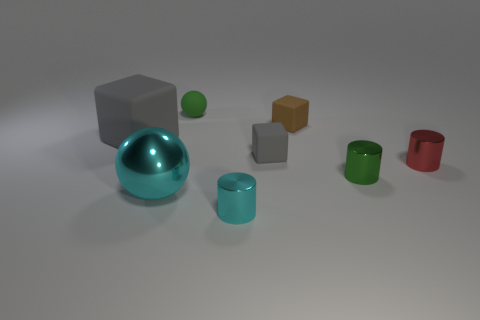How does the lighting in the image contribute to the objects' appearance? The lighting in the image is coming from above, creating soft shadows beneath each object. The gentle lighting enhances the three-dimensionality of the objects and highlights the shiny surface of the turquoise sphere, making it stand out as the most reflective among them. 